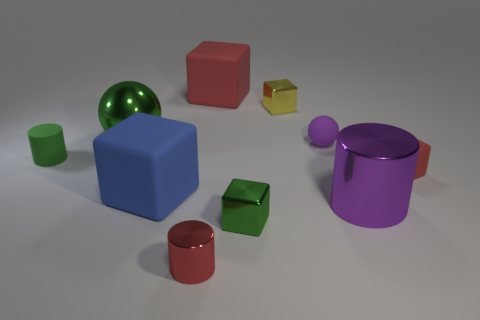Subtract all small red blocks. How many blocks are left? 4 Subtract all balls. How many objects are left? 8 Subtract 5 blocks. How many blocks are left? 0 Add 2 small rubber cylinders. How many small rubber cylinders are left? 3 Add 1 large purple cylinders. How many large purple cylinders exist? 2 Subtract all purple spheres. How many spheres are left? 1 Subtract 1 green cylinders. How many objects are left? 9 Subtract all blue cylinders. Subtract all purple balls. How many cylinders are left? 3 Subtract all purple cylinders. How many gray cubes are left? 0 Subtract all small matte spheres. Subtract all large cubes. How many objects are left? 7 